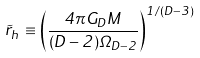Convert formula to latex. <formula><loc_0><loc_0><loc_500><loc_500>\tilde { r } _ { h } \equiv \left ( \frac { 4 \pi G _ { D } M } { ( D - 2 ) \Omega _ { D - 2 } } \right ) ^ { 1 / ( D - 3 ) }</formula> 